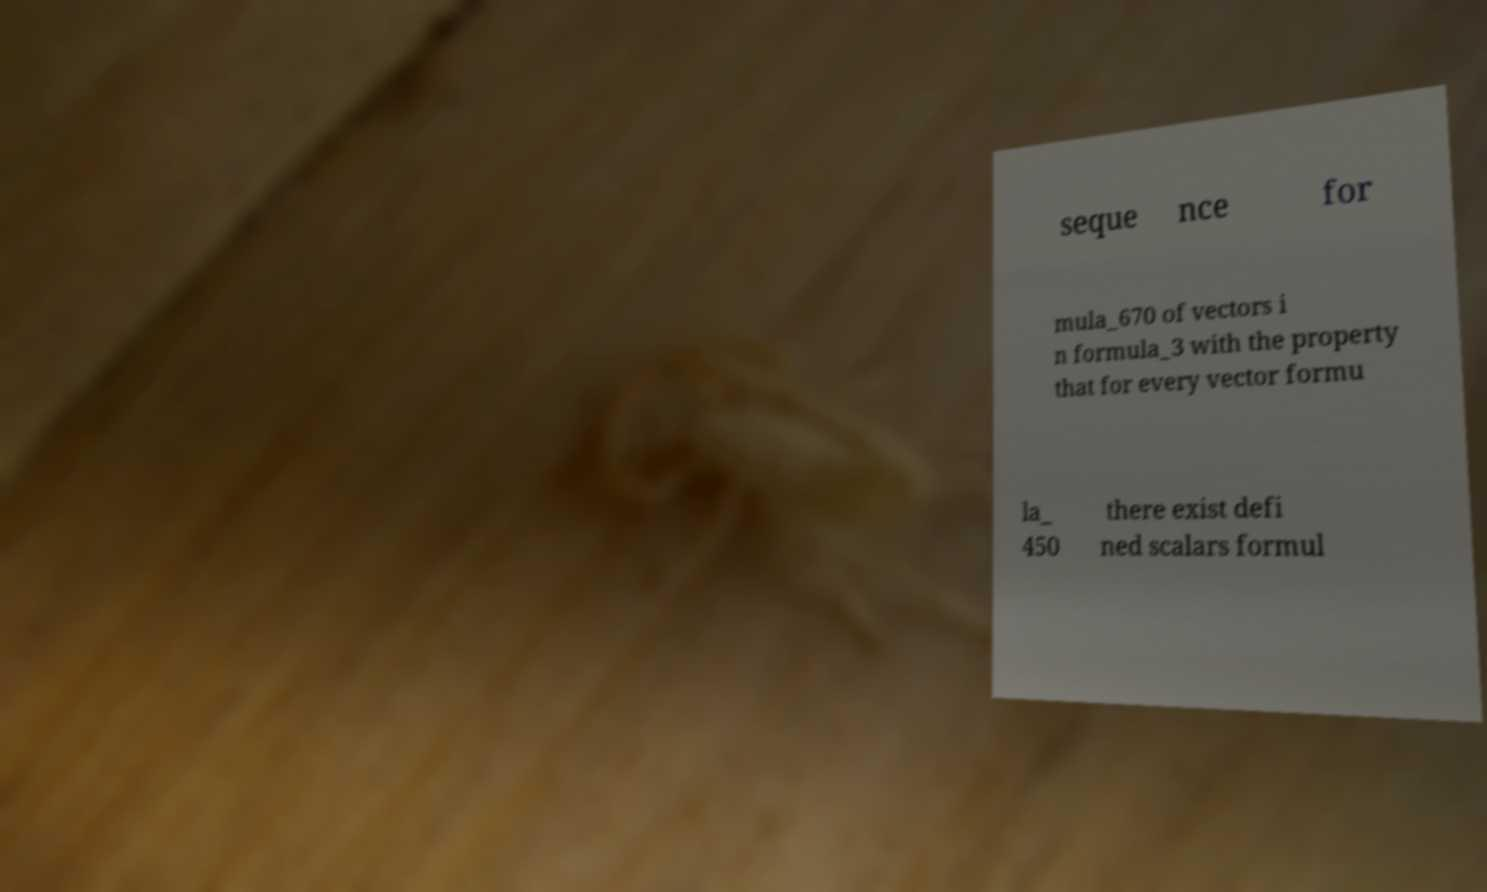Can you read and provide the text displayed in the image?This photo seems to have some interesting text. Can you extract and type it out for me? seque nce for mula_670 of vectors i n formula_3 with the property that for every vector formu la_ 450 there exist defi ned scalars formul 